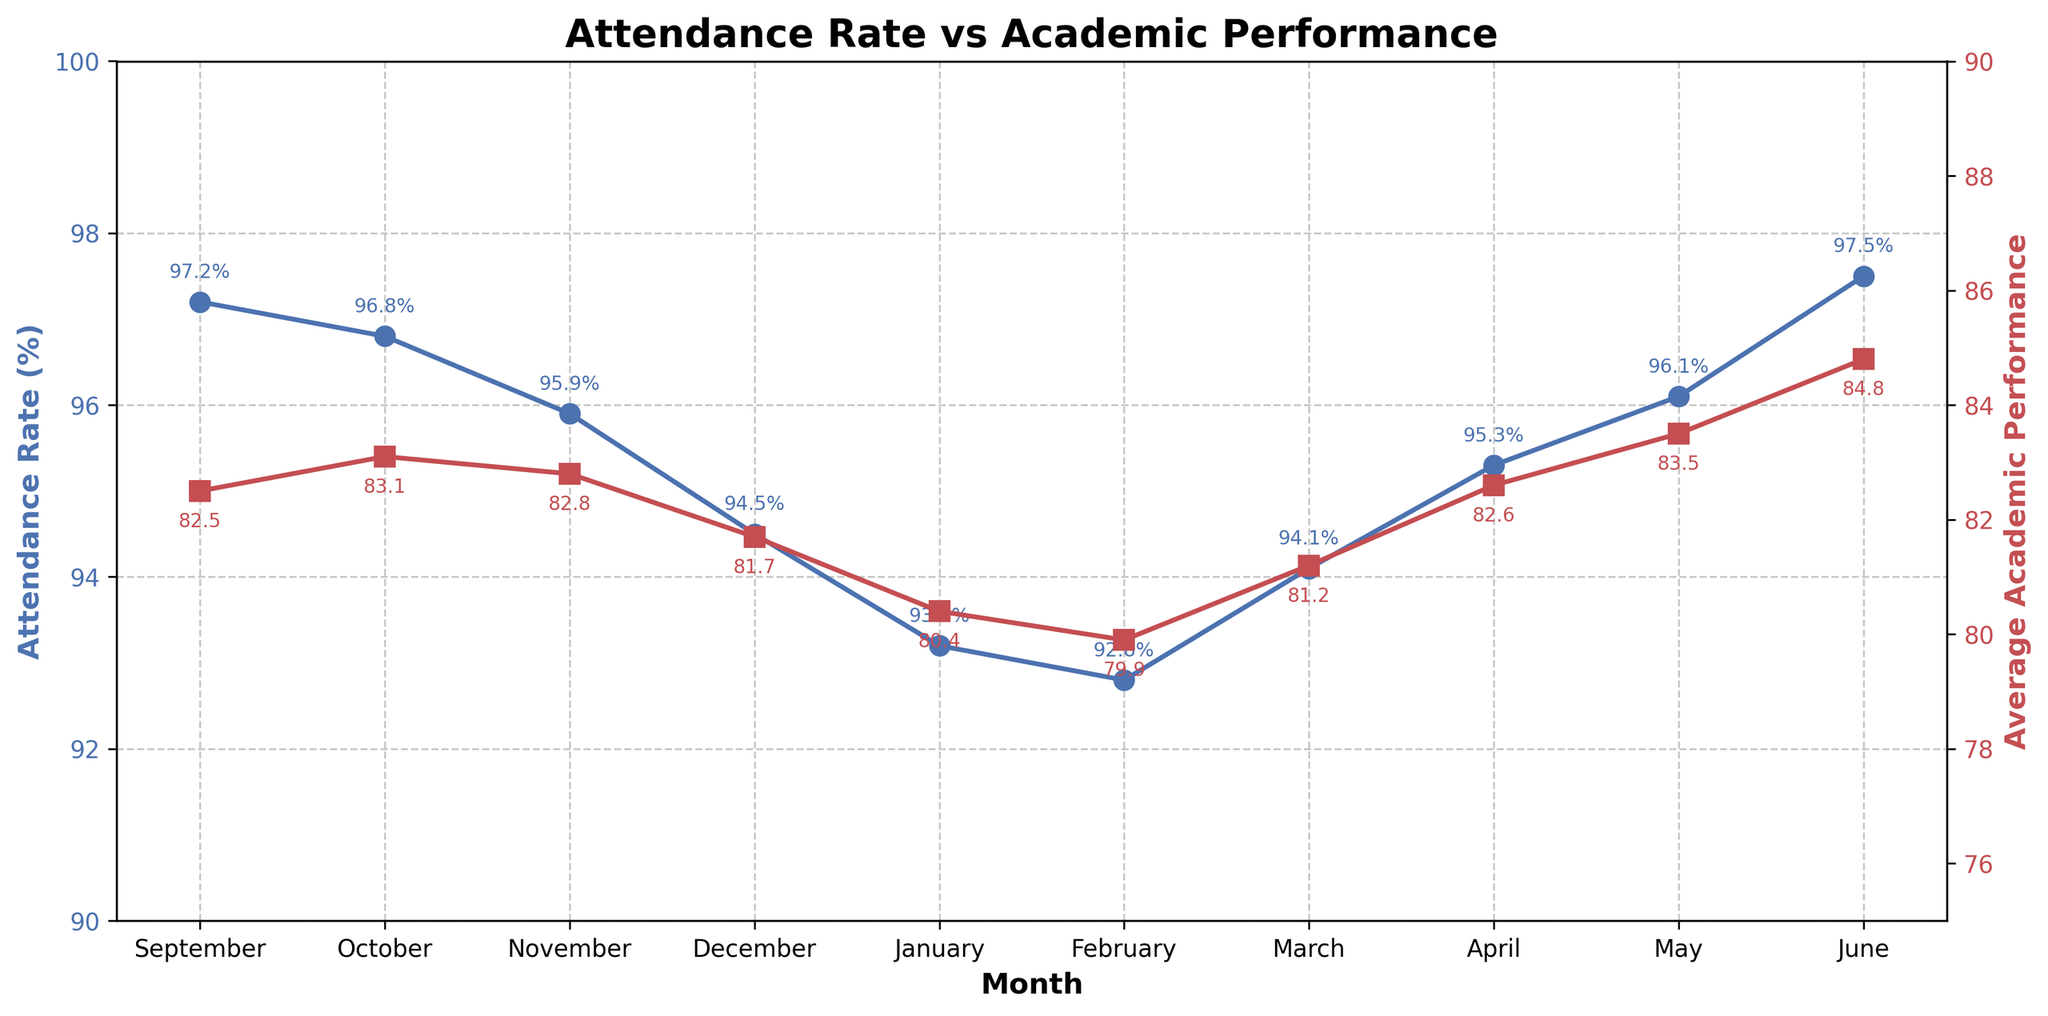What is the attendance rate in January? The data point for January in the blue line shows an attendance rate of 93.2%.
Answer: 93.2% In which month is the average academic performance the highest? The red line peaks at its highest in June with an average academic performance of 84.8.
Answer: June How does the attendance rate in February compare to that in April? The blue line shows an attendance rate of 92.8% in February and 95.3% in April. The attendance rate in February is lower than in April.
Answer: Lower What is the average attendance rate between September and December? The attendance rates from September to December are 97.2%, 96.8%, 95.9%, and 94.5%. Adding these up gives 384.4% and dividing by 4 gives 96.1%.
Answer: 96.1% Is there any month where the attendance rate increases but average academic performance decreases? From March to April, the attendance rate increases from 94.1% to 95.3%, while average academic performance also increases from 81.2 to 82.6, so we need to check other periods. There are no other months where attendance increases and performance decreases. Therefore, no such month exists.
Answer: No What is the difference between the average academic performance in September and January? The average academic performance is 82.5 in September and 80.4 in January. The difference is calculated as 82.5 - 80.4 = 2.1.
Answer: 2.1 During which months does the attendance rate drop consecutively? The blue line shows that the attendance rate drops consecutively from September to February with the rates as follows: 97.2%, 96.8%, 95.9%, 94.5%, 93.2%, and 92.8%.
Answer: September to February Which month has the largest gap between attendance rate and average academic performance? The gap is visually the largest in January, where the attendance rate is 93.2% and the average academic performance is 80.4. The difference is 93.2 - 80.4 = 12.8, which is the largest among all months.
Answer: January What is the attendance rate trend from January to June? Observing the blue line from January to June, the attendance rate starts at 93.2% in January and steadily increases to 97.5% in June. This shows an increasing trend.
Answer: Increasing 